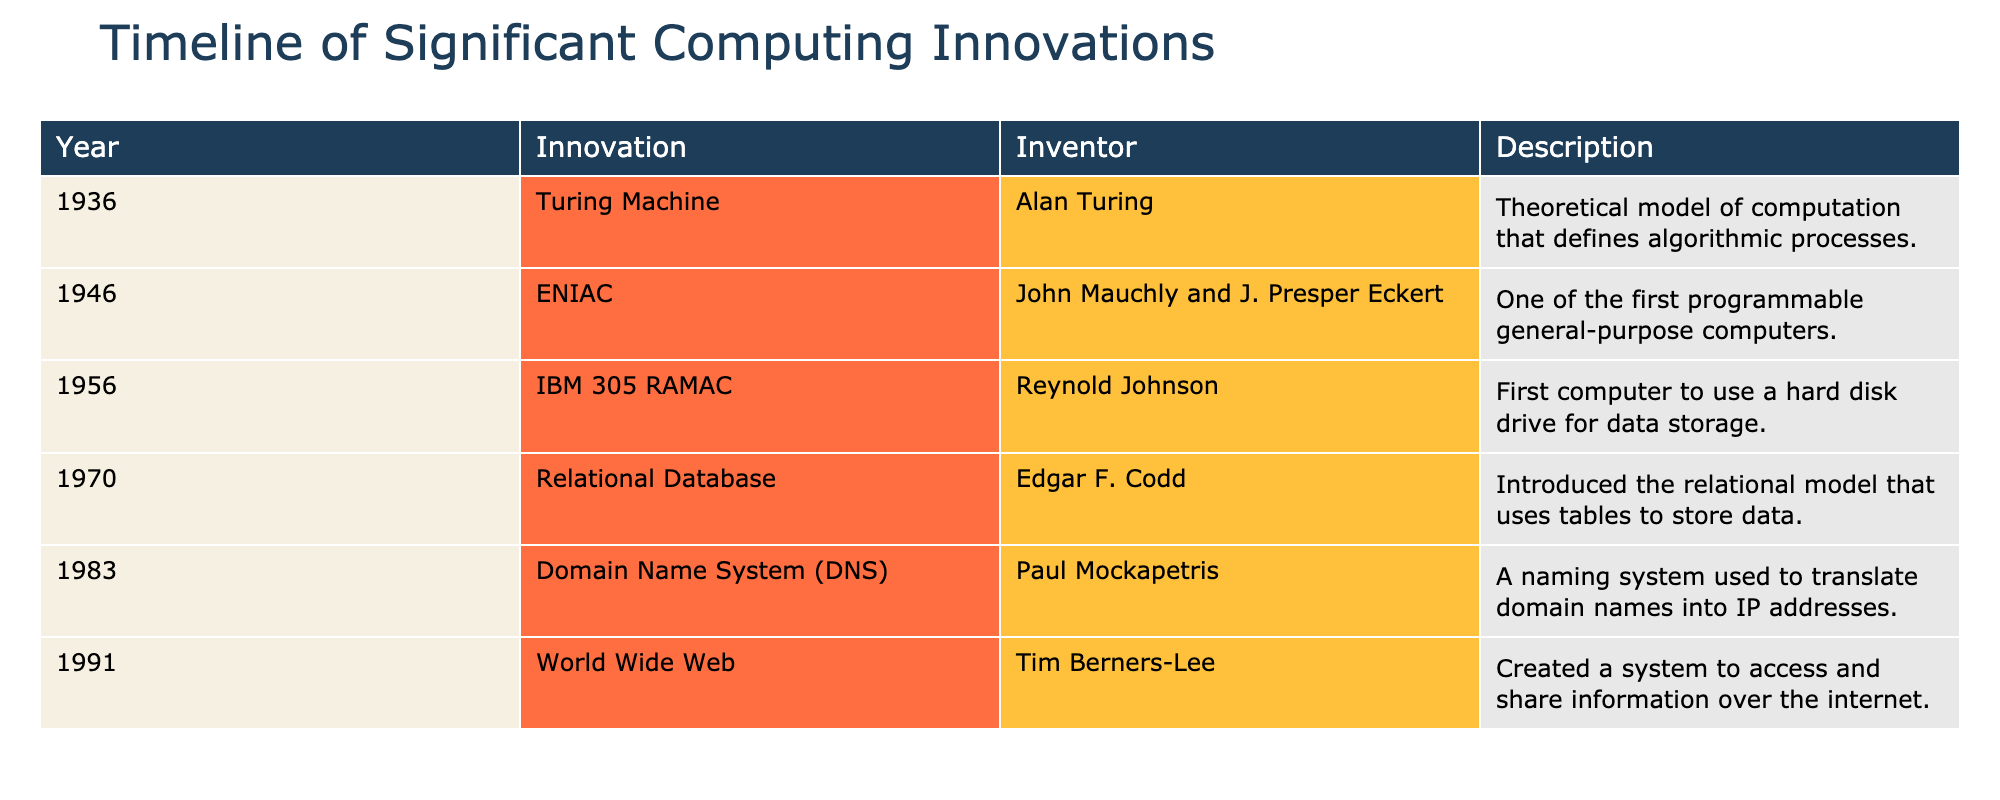What year was the ENIAC introduced? The table lists the year of significant computing innovations. By locating ENIAC in the innovation column, we see that it was introduced in 1946.
Answer: 1946 Who invented the Turing Machine? The table shows that Alan Turing is listed as the inventor of the Turing Machine, which is found under the innovation column for the year 1936.
Answer: Alan Turing What innovation was developed in 1983? By looking at the year column, we find that the innovation listed for 1983 is the Domain Name System (DNS).
Answer: Domain Name System (DNS) How many innovations listed were introduced before 1970? The table indicates that there are three innovations (Turing Machine, ENIAC, and IBM 305 RAMAC) introduced before 1970, as they appear before that year in the table.
Answer: 3 Was the World Wide Web invented before the Domain Name System? By examining the years listed, the Domain Name System was introduced in 1983 and the World Wide Web in 1991, thus making it false that the World Wide Web was invented before the DNS.
Answer: No Who is credited with creating the World Wide Web? The table shows that Tim Berners-Lee is the inventor credited with creating the World Wide Web, as indicated in the corresponding entry for 1991.
Answer: Tim Berners-Lee Which innovation introduced a relational model for data storage? The table specifies that the Relational Database, introduced by Edgar F. Codd in 1970, is the innovation that introduced a relational model for data storage.
Answer: Relational Database What is the difference in years between the introduction of the Turing Machine and the World Wide Web? The Turing Machine was introduced in 1936 and the World Wide Web in 1991. Calculating the difference: 1991 - 1936 = 55 years.
Answer: 55 years How many inventors are mentioned in the table? By scanning through the inventor column, we see there are five unique inventors listed: Alan Turing, John Mauchly and J. Presper Eckert, Reynold Johnson, Edgar F. Codd, and Tim Berners-Lee, summing up to five.
Answer: 5 Which invention marked the beginning of modern computing in the table? Referring to the innovations, the ENIAC in 1946 is often credited as one of the first programmable general-purpose computers, marking a significant point in modern computing.
Answer: ENIAC 